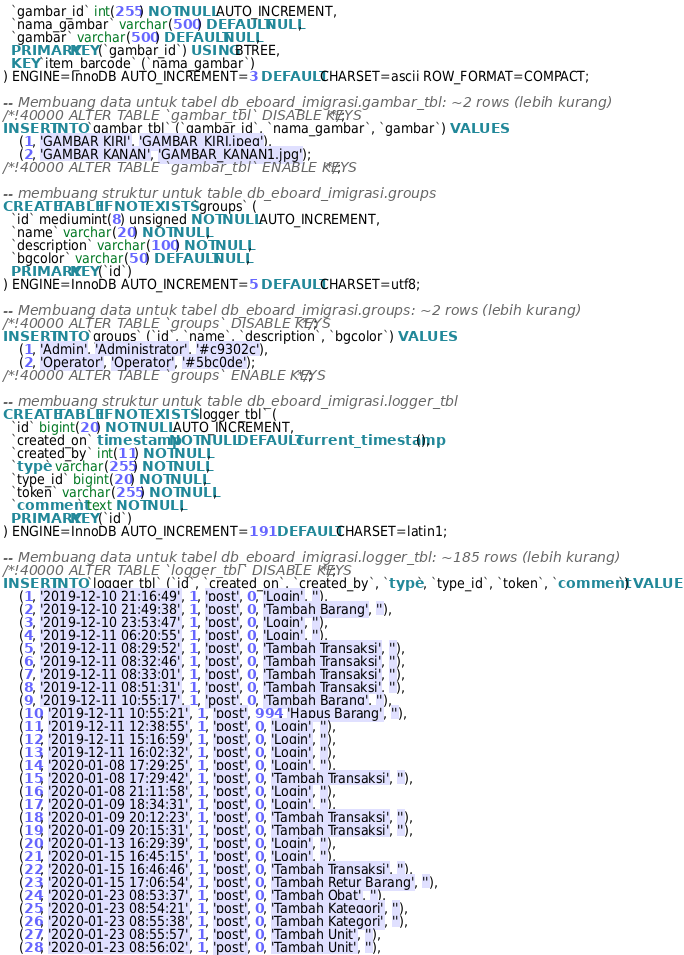<code> <loc_0><loc_0><loc_500><loc_500><_SQL_>  `gambar_id` int(255) NOT NULL AUTO_INCREMENT,
  `nama_gambar` varchar(500) DEFAULT NULL,
  `gambar` varchar(500) DEFAULT NULL,
  PRIMARY KEY (`gambar_id`) USING BTREE,
  KEY `item_barcode` (`nama_gambar`)
) ENGINE=InnoDB AUTO_INCREMENT=3 DEFAULT CHARSET=ascii ROW_FORMAT=COMPACT;

-- Membuang data untuk tabel db_eboard_imigrasi.gambar_tbl: ~2 rows (lebih kurang)
/*!40000 ALTER TABLE `gambar_tbl` DISABLE KEYS */;
INSERT INTO `gambar_tbl` (`gambar_id`, `nama_gambar`, `gambar`) VALUES
	(1, 'GAMBAR KIRI', 'GAMBAR_KIRI.jpeg'),
	(2, 'GAMBAR KANAN', 'GAMBAR_KANAN1.jpg');
/*!40000 ALTER TABLE `gambar_tbl` ENABLE KEYS */;

-- membuang struktur untuk table db_eboard_imigrasi.groups
CREATE TABLE IF NOT EXISTS `groups` (
  `id` mediumint(8) unsigned NOT NULL AUTO_INCREMENT,
  `name` varchar(20) NOT NULL,
  `description` varchar(100) NOT NULL,
  `bgcolor` varchar(50) DEFAULT NULL,
  PRIMARY KEY (`id`)
) ENGINE=InnoDB AUTO_INCREMENT=5 DEFAULT CHARSET=utf8;

-- Membuang data untuk tabel db_eboard_imigrasi.groups: ~2 rows (lebih kurang)
/*!40000 ALTER TABLE `groups` DISABLE KEYS */;
INSERT INTO `groups` (`id`, `name`, `description`, `bgcolor`) VALUES
	(1, 'Admin', 'Administrator', '#c9302c'),
	(2, 'Operator', 'Operator', '#5bc0de');
/*!40000 ALTER TABLE `groups` ENABLE KEYS */;

-- membuang struktur untuk table db_eboard_imigrasi.logger_tbl
CREATE TABLE IF NOT EXISTS `logger_tbl` (
  `id` bigint(20) NOT NULL AUTO_INCREMENT,
  `created_on` timestamp NOT NULL DEFAULT current_timestamp(),
  `created_by` int(11) NOT NULL,
  `type` varchar(255) NOT NULL,
  `type_id` bigint(20) NOT NULL,
  `token` varchar(255) NOT NULL,
  `comment` text NOT NULL,
  PRIMARY KEY (`id`)
) ENGINE=InnoDB AUTO_INCREMENT=191 DEFAULT CHARSET=latin1;

-- Membuang data untuk tabel db_eboard_imigrasi.logger_tbl: ~185 rows (lebih kurang)
/*!40000 ALTER TABLE `logger_tbl` DISABLE KEYS */;
INSERT INTO `logger_tbl` (`id`, `created_on`, `created_by`, `type`, `type_id`, `token`, `comment`) VALUES
	(1, '2019-12-10 21:16:49', 1, 'post', 0, 'Login', ''),
	(2, '2019-12-10 21:49:38', 1, 'post', 0, 'Tambah Barang', ''),
	(3, '2019-12-10 23:53:47', 1, 'post', 0, 'Login', ''),
	(4, '2019-12-11 06:20:55', 1, 'post', 0, 'Login', ''),
	(5, '2019-12-11 08:29:52', 1, 'post', 0, 'Tambah Transaksi', ''),
	(6, '2019-12-11 08:32:46', 1, 'post', 0, 'Tambah Transaksi', ''),
	(7, '2019-12-11 08:33:01', 1, 'post', 0, 'Tambah Transaksi', ''),
	(8, '2019-12-11 08:51:31', 1, 'post', 0, 'Tambah Transaksi', ''),
	(9, '2019-12-11 10:55:17', 1, 'post', 0, 'Tambah Barang', ''),
	(10, '2019-12-11 10:55:21', 1, 'post', 994, 'Hapus Barang', ''),
	(11, '2019-12-11 12:38:55', 1, 'post', 0, 'Login', ''),
	(12, '2019-12-11 15:16:59', 1, 'post', 0, 'Login', ''),
	(13, '2019-12-11 16:02:32', 1, 'post', 0, 'Login', ''),
	(14, '2020-01-08 17:29:25', 1, 'post', 0, 'Login', ''),
	(15, '2020-01-08 17:29:42', 1, 'post', 0, 'Tambah Transaksi', ''),
	(16, '2020-01-08 21:11:58', 1, 'post', 0, 'Login', ''),
	(17, '2020-01-09 18:34:31', 1, 'post', 0, 'Login', ''),
	(18, '2020-01-09 20:12:23', 1, 'post', 0, 'Tambah Transaksi', ''),
	(19, '2020-01-09 20:15:31', 1, 'post', 0, 'Tambah Transaksi', ''),
	(20, '2020-01-13 16:29:39', 1, 'post', 0, 'Login', ''),
	(21, '2020-01-15 16:45:15', 1, 'post', 0, 'Login', ''),
	(22, '2020-01-15 16:46:46', 1, 'post', 0, 'Tambah Transaksi', ''),
	(23, '2020-01-15 17:06:54', 1, 'post', 0, 'Tambah Retur Barang', ''),
	(24, '2020-01-23 08:53:37', 1, 'post', 0, 'Tambah Obat', ''),
	(25, '2020-01-23 08:54:21', 1, 'post', 0, 'Tambah Kategori', ''),
	(26, '2020-01-23 08:55:38', 1, 'post', 0, 'Tambah Kategori', ''),
	(27, '2020-01-23 08:55:57', 1, 'post', 0, 'Tambah Unit', ''),
	(28, '2020-01-23 08:56:02', 1, 'post', 0, 'Tambah Unit', ''),</code> 